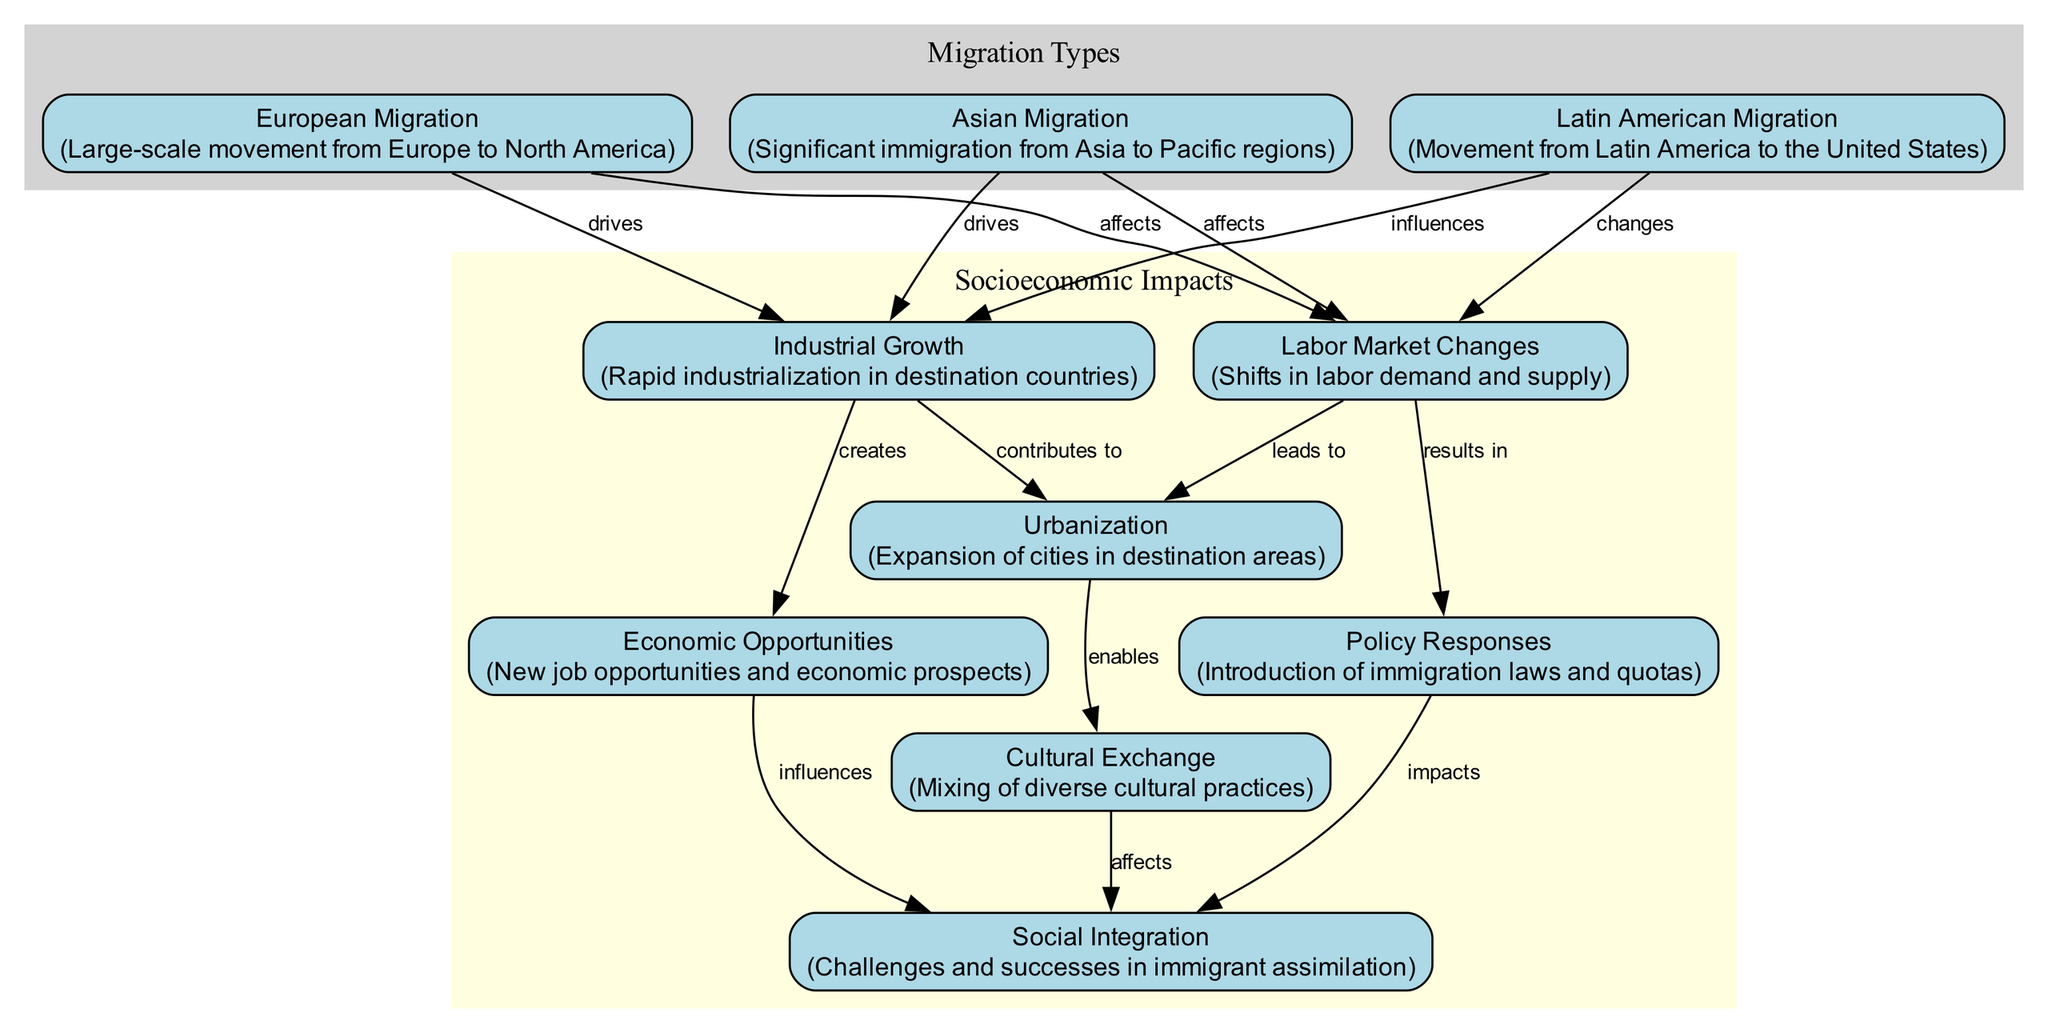What are the three main types of migration depicted in the diagram? The diagram highlights three main types of migration: European Migration, Asian Migration, and Latin American Migration. These are distinctly labeled in the diagram as individual nodes.
Answer: European Migration, Asian Migration, Latin American Migration Which socioeconomic impact is directly created by Industrial Growth? The diagram shows an edge labeled "creates" from Industrial Growth to Economic Opportunities, indicating a direct connection where economic opportunities arise from industrial growth.
Answer: Economic Opportunities How many edges are connecting the migration nodes to socioeconomic impacts? Counting the edges that connect the migration nodes (1, 2, and 3) to the socioeconomic nodes (4, 5, 6, 9), there are a total of six edges leading from migration to socioeconomic impacts.
Answer: 6 What does the Cultural Exchange node enable? The diagram shows an edge labeled "enables" from Urbanization to Cultural Exchange, indicating that urbanization facilitates cultural exchange between diverse groups.
Answer: Cultural Exchange Which response policy affects social integration? The diagram indicates an edge labeled "impacts" from Policy Responses to Social Integration, suggesting that the policies put in place to manage immigration influence social integration.
Answer: Social Integration What drives labor market changes according to the diagram? The diagram shows edges labeled "affects" connecting both European Migration and Asian Migration to Labor Market Changes, meaning both types of migration drive changes in the labor market.
Answer: European Migration, Asian Migration 